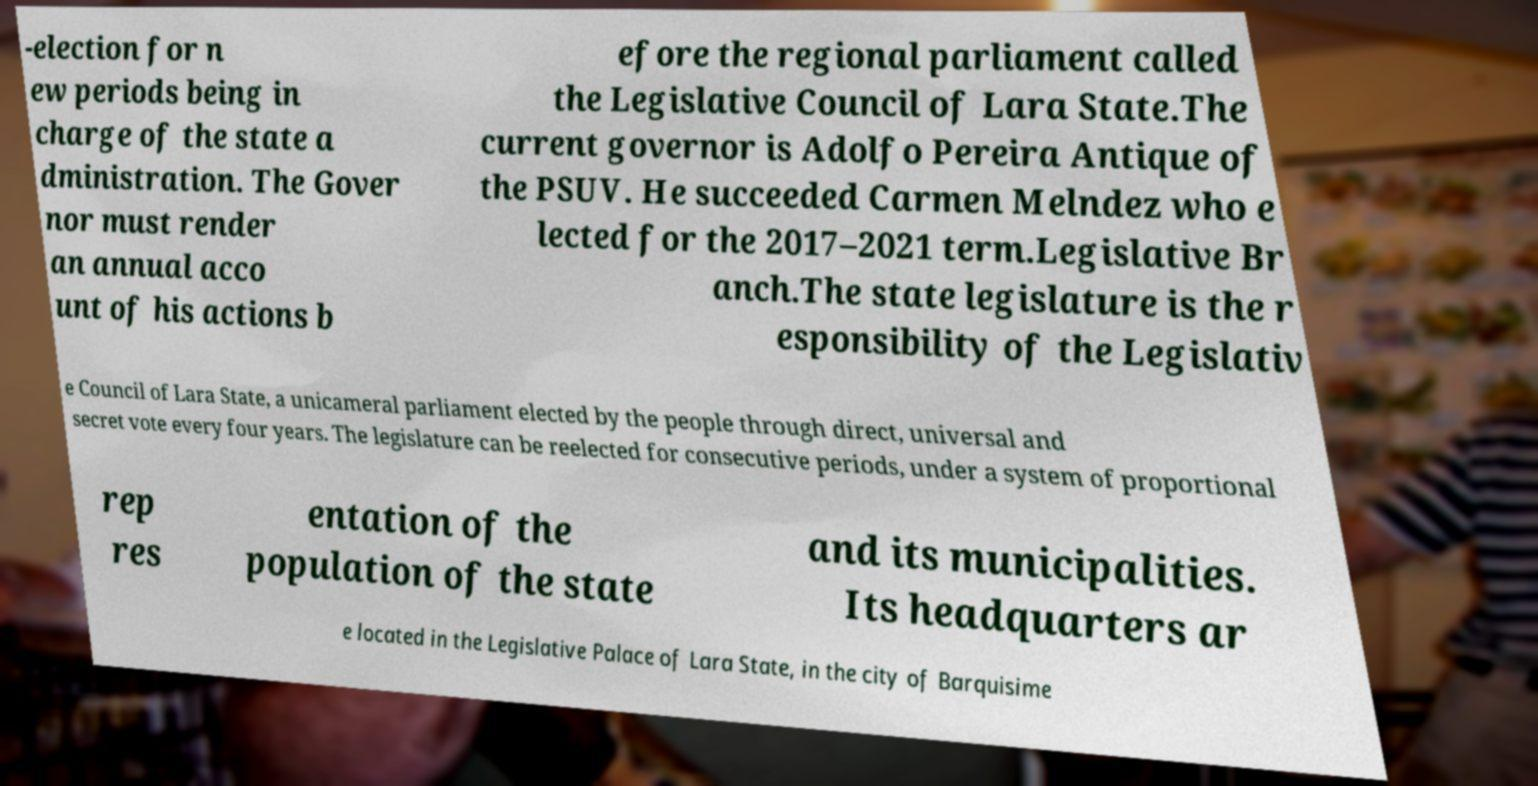Can you read and provide the text displayed in the image?This photo seems to have some interesting text. Can you extract and type it out for me? -election for n ew periods being in charge of the state a dministration. The Gover nor must render an annual acco unt of his actions b efore the regional parliament called the Legislative Council of Lara State.The current governor is Adolfo Pereira Antique of the PSUV. He succeeded Carmen Melndez who e lected for the 2017–2021 term.Legislative Br anch.The state legislature is the r esponsibility of the Legislativ e Council of Lara State, a unicameral parliament elected by the people through direct, universal and secret vote every four years. The legislature can be reelected for consecutive periods, under a system of proportional rep res entation of the population of the state and its municipalities. Its headquarters ar e located in the Legislative Palace of Lara State, in the city of Barquisime 